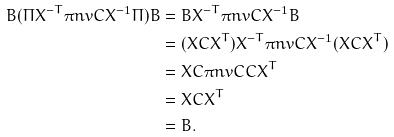Convert formula to latex. <formula><loc_0><loc_0><loc_500><loc_500>B ( \Pi X ^ { - T } \pi n v { C } X ^ { - 1 } \Pi ) B & = B X ^ { - T } \pi n v { C } X ^ { - 1 } B \\ & = ( X C X ^ { T } ) X ^ { - T } \pi n v { C } X ^ { - 1 } ( X C X ^ { T } ) \\ & = X C \pi n v { C } C X ^ { T } \\ & = X C X ^ { T } \\ & = B .</formula> 